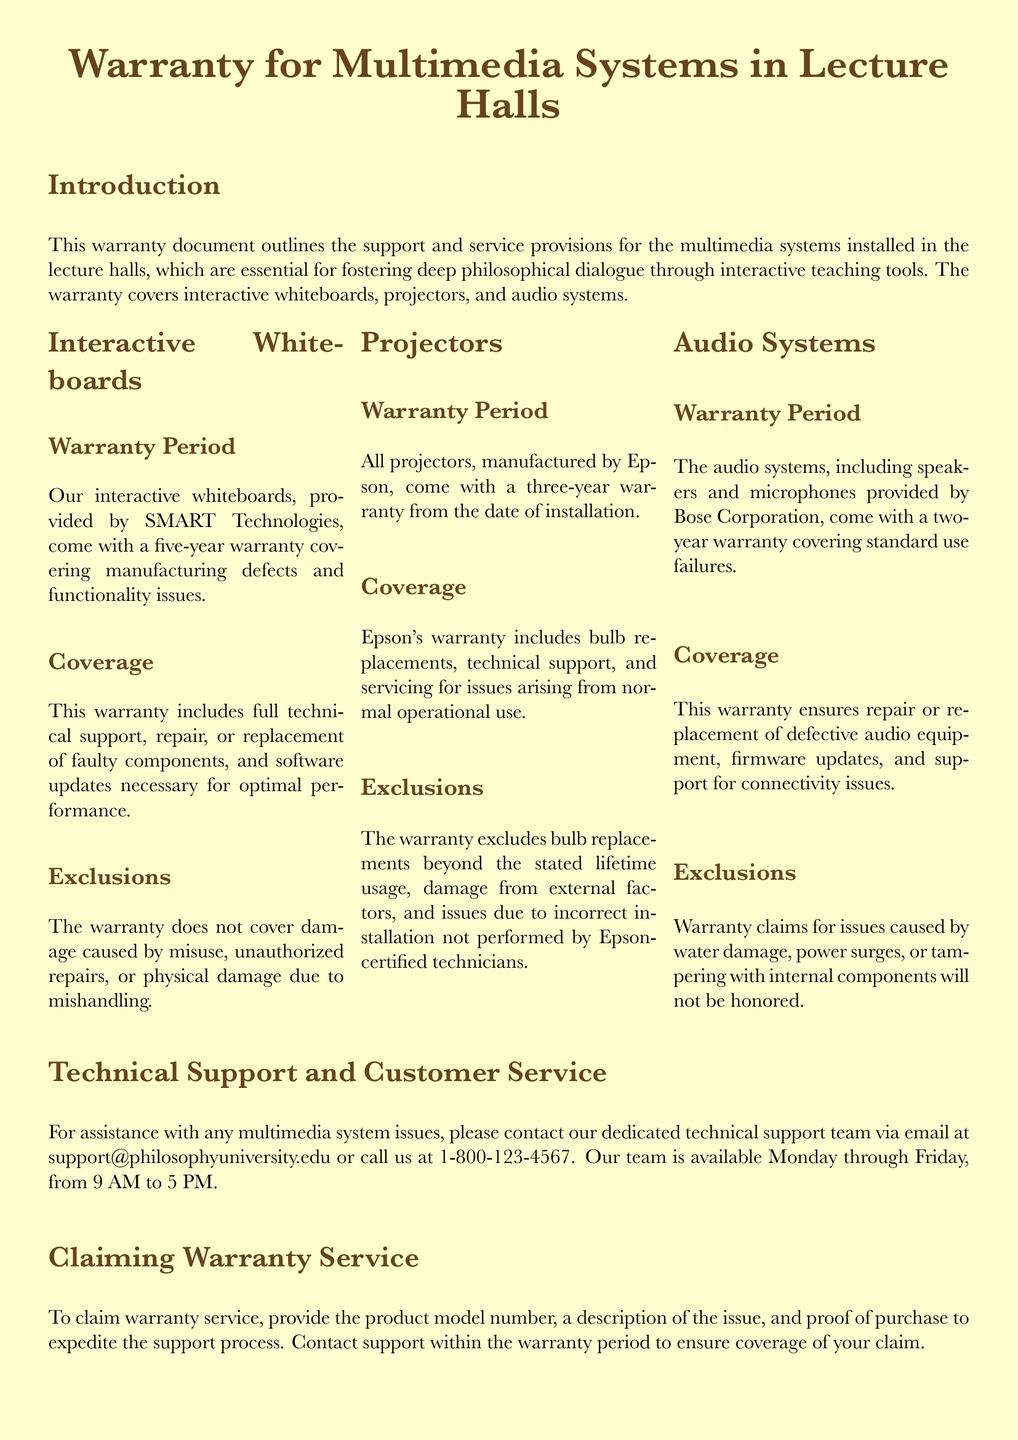What is the warranty period for interactive whiteboards? The warranty period for interactive whiteboards is stated in the document as five years.
Answer: five years What is included in the projector warranty coverage? The coverage details for projectors include bulb replacements, technical support, and servicing for issues arising from normal operational use.
Answer: bulb replacements, technical support, servicing What company provides the audio systems? The audio systems are provided by Bose Corporation as mentioned in the warranty.
Answer: Bose Corporation What exclusions apply to the whiteboard warranty? The exclusions for the whiteboard warranty include damage caused by misuse, unauthorized repairs, or physical damage due to mishandling.
Answer: misuse, unauthorized repairs, physical damage Which department should be contacted for technical support? The document specifies that the dedicated technical support team should be contacted for multimedia system issues.
Answer: technical support team How long is the warranty period for projectors? According to the document, projectors come with a warranty period of three years from the date of installation.
Answer: three years What is required to claim warranty service? To claim warranty service, the document states that the product model number, a description of the issue, and proof of purchase are needed to expedite the support process.
Answer: model number, description of the issue, proof of purchase What support does the audio system warranty guarantee? The audio system warranty guarantees repair or replacement of defective audio equipment, firmware updates, and support for connectivity issues.
Answer: repair, firmware updates, support What should customers do to ensure the warranty covers their claim? Customers must contact support within the warranty period to ensure coverage of their claim as specified in the document.
Answer: contact support within warranty period 